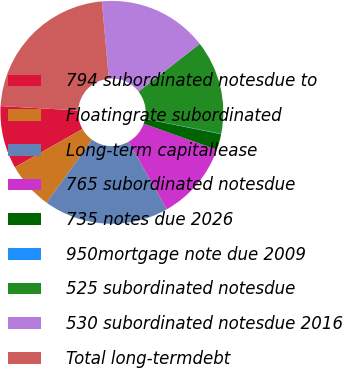Convert chart. <chart><loc_0><loc_0><loc_500><loc_500><pie_chart><fcel>794 subordinated notesdue to<fcel>Floatingrate subordinated<fcel>Long-term capitallease<fcel>765 subordinated notesdue<fcel>735 notes due 2026<fcel>950mortgage note due 2009<fcel>525 subordinated notesdue<fcel>530 subordinated notesdue 2016<fcel>Total long-termdebt<nl><fcel>9.1%<fcel>6.84%<fcel>18.15%<fcel>11.36%<fcel>2.31%<fcel>0.05%<fcel>13.62%<fcel>15.89%<fcel>22.67%<nl></chart> 